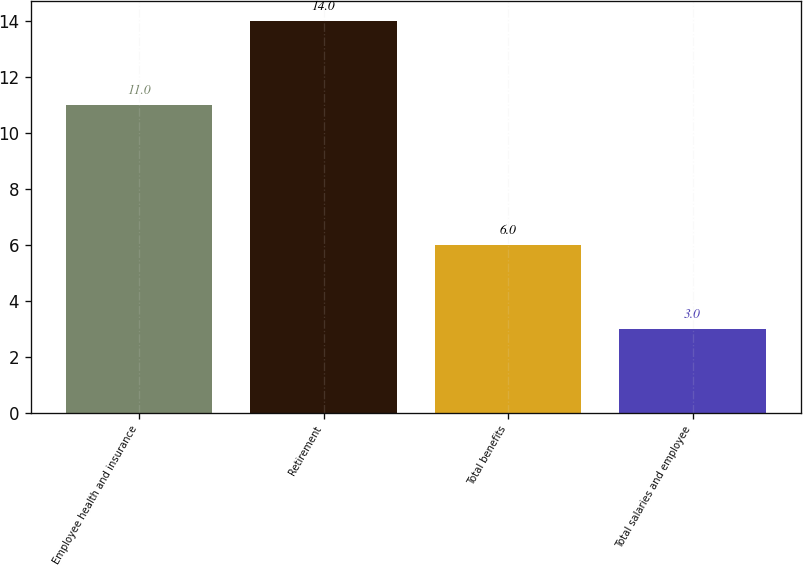<chart> <loc_0><loc_0><loc_500><loc_500><bar_chart><fcel>Employee health and insurance<fcel>Retirement<fcel>Total benefits<fcel>Total salaries and employee<nl><fcel>11<fcel>14<fcel>6<fcel>3<nl></chart> 